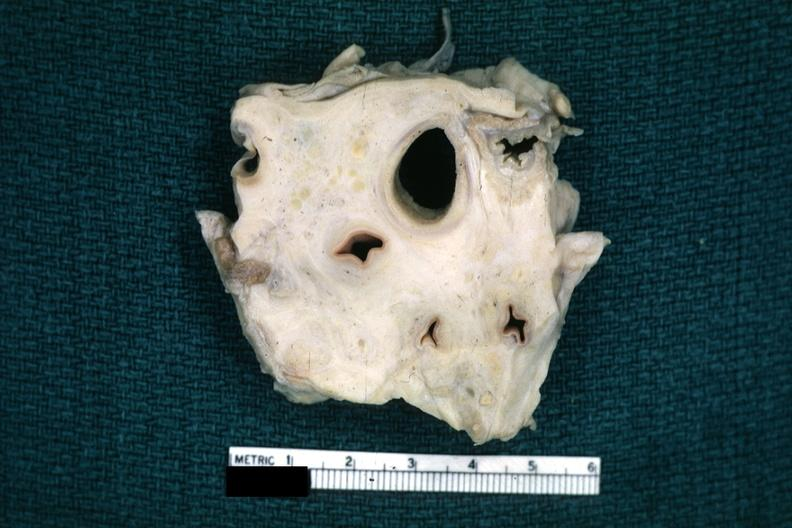what does this image show?
Answer the question using a single word or phrase. Fixed tissue trachea and arteries surrounded by dense tumor tissue horizontal section 